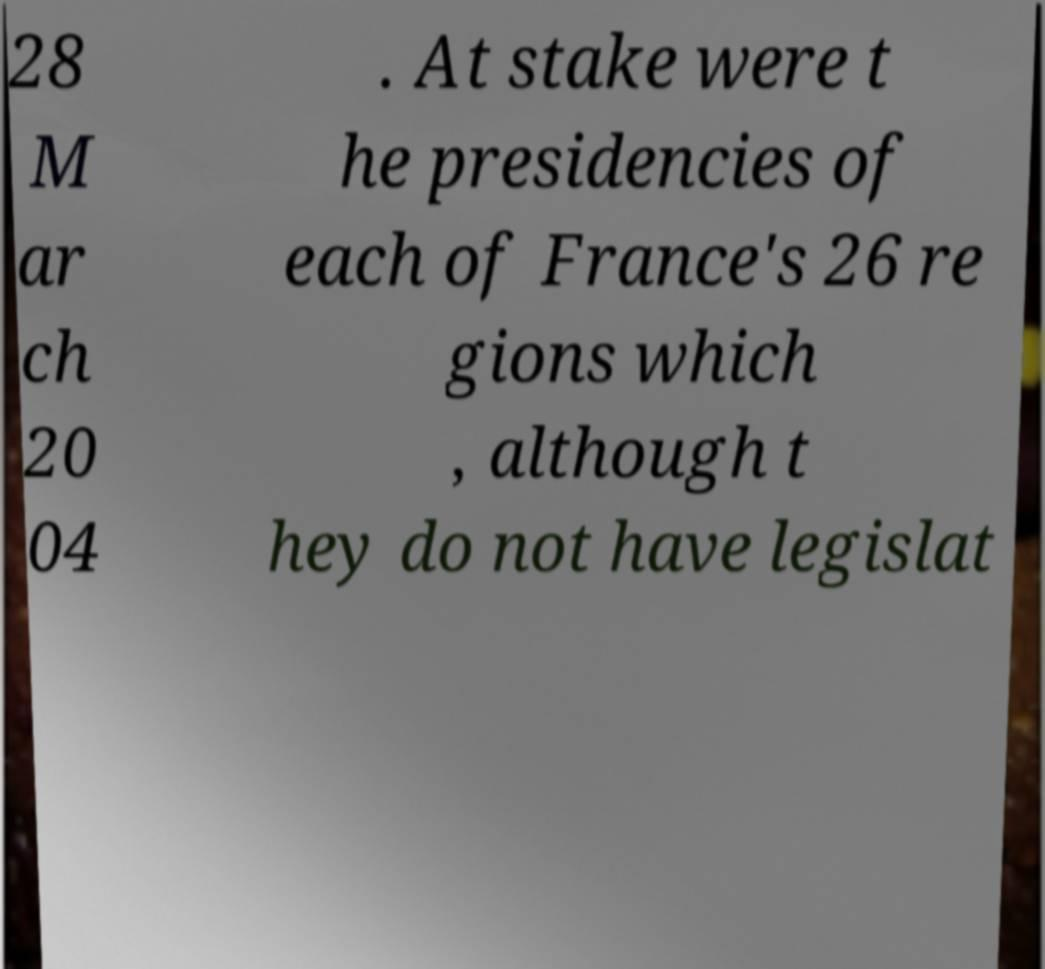For documentation purposes, I need the text within this image transcribed. Could you provide that? 28 M ar ch 20 04 . At stake were t he presidencies of each of France's 26 re gions which , although t hey do not have legislat 